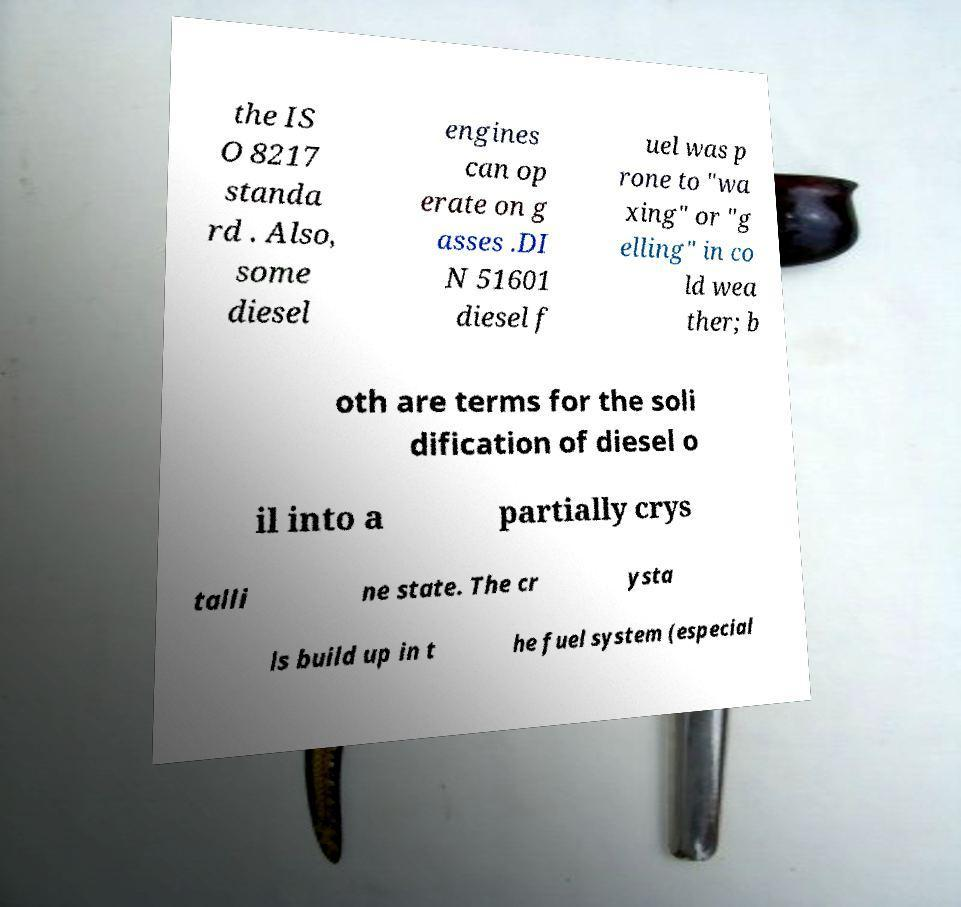There's text embedded in this image that I need extracted. Can you transcribe it verbatim? the IS O 8217 standa rd . Also, some diesel engines can op erate on g asses .DI N 51601 diesel f uel was p rone to "wa xing" or "g elling" in co ld wea ther; b oth are terms for the soli dification of diesel o il into a partially crys talli ne state. The cr ysta ls build up in t he fuel system (especial 